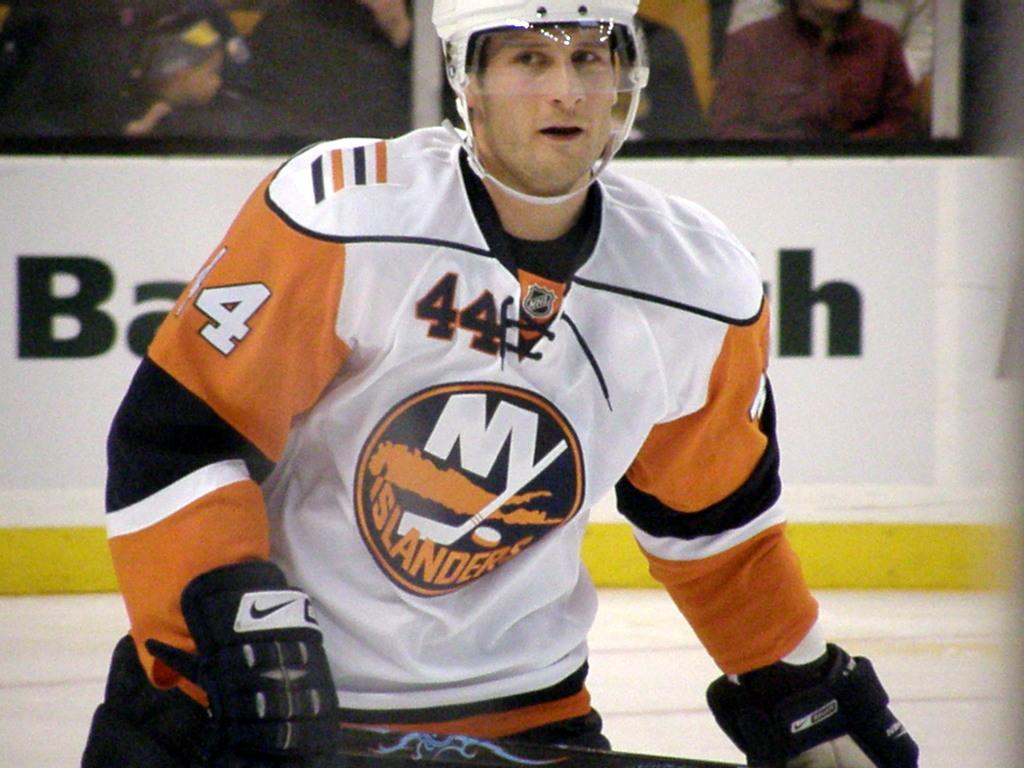What can be seen in the image? There is a person in the image. What is the person doing in the image? The person is holding an object. What is the background of the image? There is a white background behind the person. Are there any other people in the image? Yes, there are audience members sitting in the image. What type of insect can be seen flying around the person in the image? There are no insects visible in the image. What kind of sail is attached to the person in the image? There is no sail present in the image. 